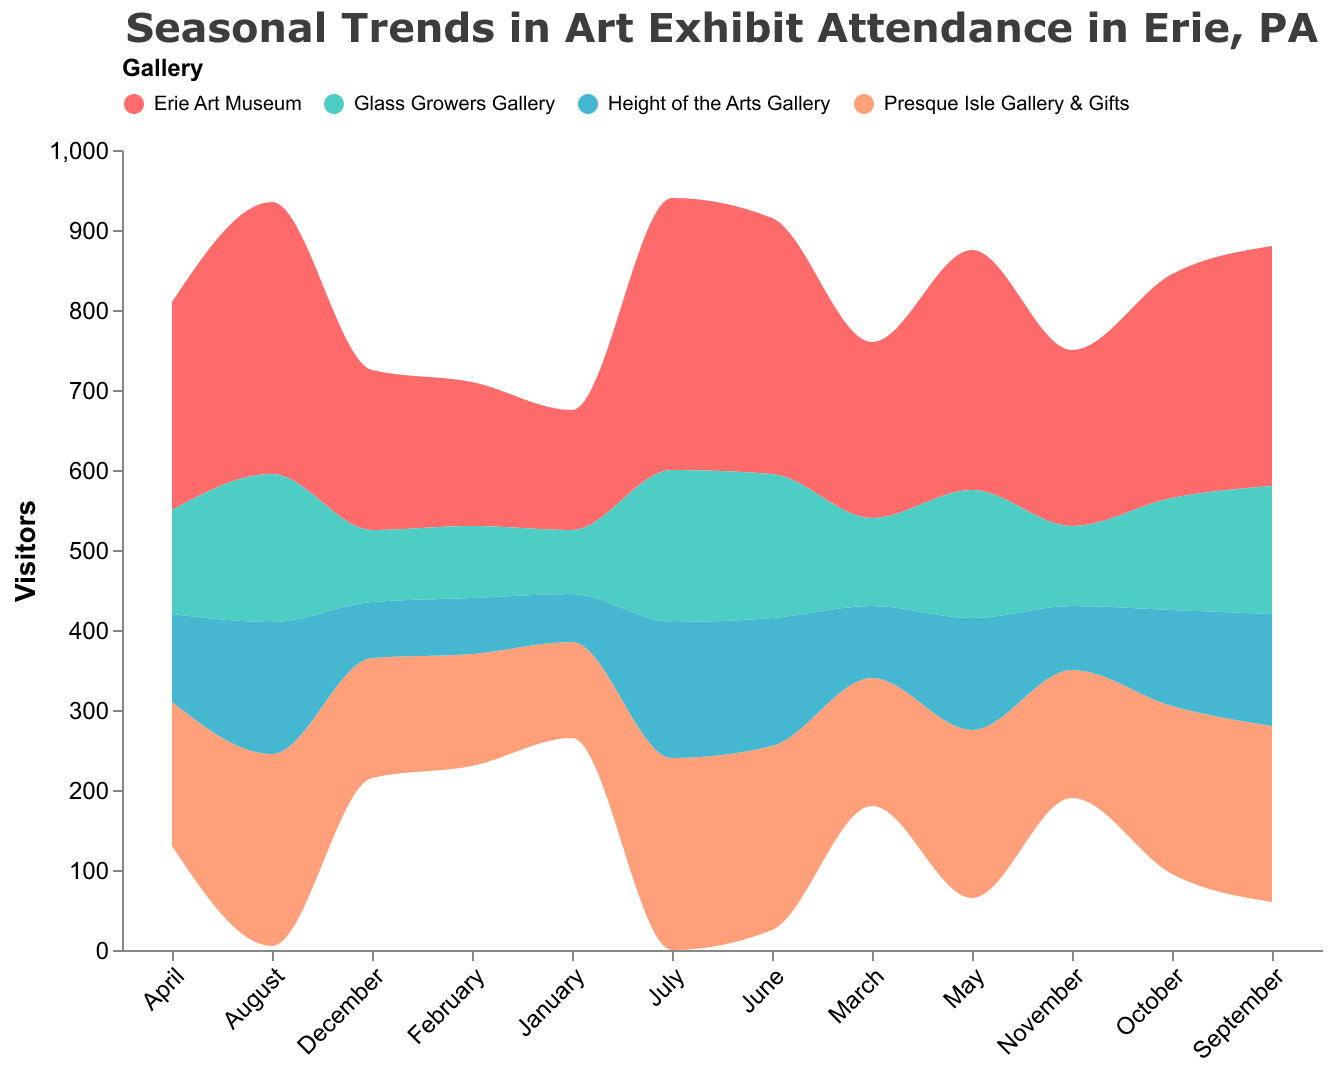What's the title of the figure? The title of the figure is found at the top of the graph, showing the overall subject of the displayed data.
Answer: Seasonal Trends in Art Exhibit Attendance in Erie, PA Which gallery has the highest attendance in August? In August, we look for the peak value in the color associated with each gallery. The Erie Art Museum has the peak attendance with 340 visitors.
Answer: Erie Art Museum How does the attendance of the Presque Isle Gallery & Gifts in April compare to that in October? We find the attendance values for the Presque Isle Gallery & Gifts in both April and October by looking at the corresponding sections of the stream. In April, it is 180, and in October, it is 210. The attendance in October is higher.
Answer: October What can you say about the seasonal pattern of the Erie Art Museum's attendance? The attendance for the Erie Art Museum increases from January, peaks in July and August, and then decreases towards the end of the year.
Answer: Peaks in July and August, decreases towards the end of the year Which month has the lowest combined attendance for all the galleries? We sum the attendance for all galleries in each month and compare them. January has the combined attendance of 410 (150 + 120 + 80 + 60).
Answer: January What is the difference in attendance between the Erie Art Museum and the Glass Growers Gallery in March? The Erie Art Museum's attendance in March is 220, and the Glass Growers Gallery’s attendance is 110. The difference is 220 - 110.
Answer: 110 What is the total attendance for the Height of the Arts Gallery over the entire year? Sum the monthly attendance values for the Height of the Arts Gallery: 60 + 70 + 90 + 110 + 140 + 160 + 170 + 165 + 140 + 120 + 80 + 70. The total sum is 1375.
Answer: 1375 Does the Glass Growers Gallery have a higher attendance in June or August? By checking the values of Glass Growers Gallery in June (180) and August (185), August is higher than June.
Answer: August Which gallery experiences the most significant increase in attendance from January to July? Calculate the increase for each gallery: 
Erie Art Museum: 340 - 150 = 190, 
Presque Isle Gallery & Gifts: 240 - 120 = 120, 
Glass Growers Gallery: 190 - 80 = 110, 
Height of the Arts Gallery: 170 - 60 = 110. 
The Erie Art Museum has the greatest increase.
Answer: Erie Art Museum 